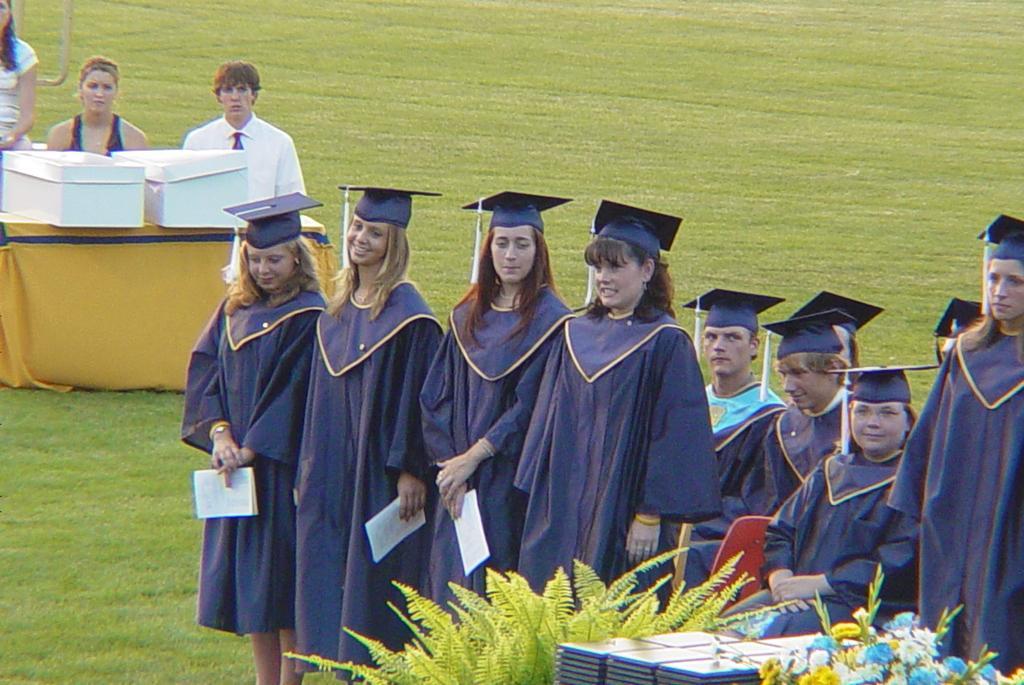Could you give a brief overview of what you see in this image? In the image in the center, we can see a few people are sitting and few people are standing. And they are smiling, which we can see on their faces. In front of them, we can see plants, flowers and boxes. In the background we can see grass, one table, boxes and few people are standing. 